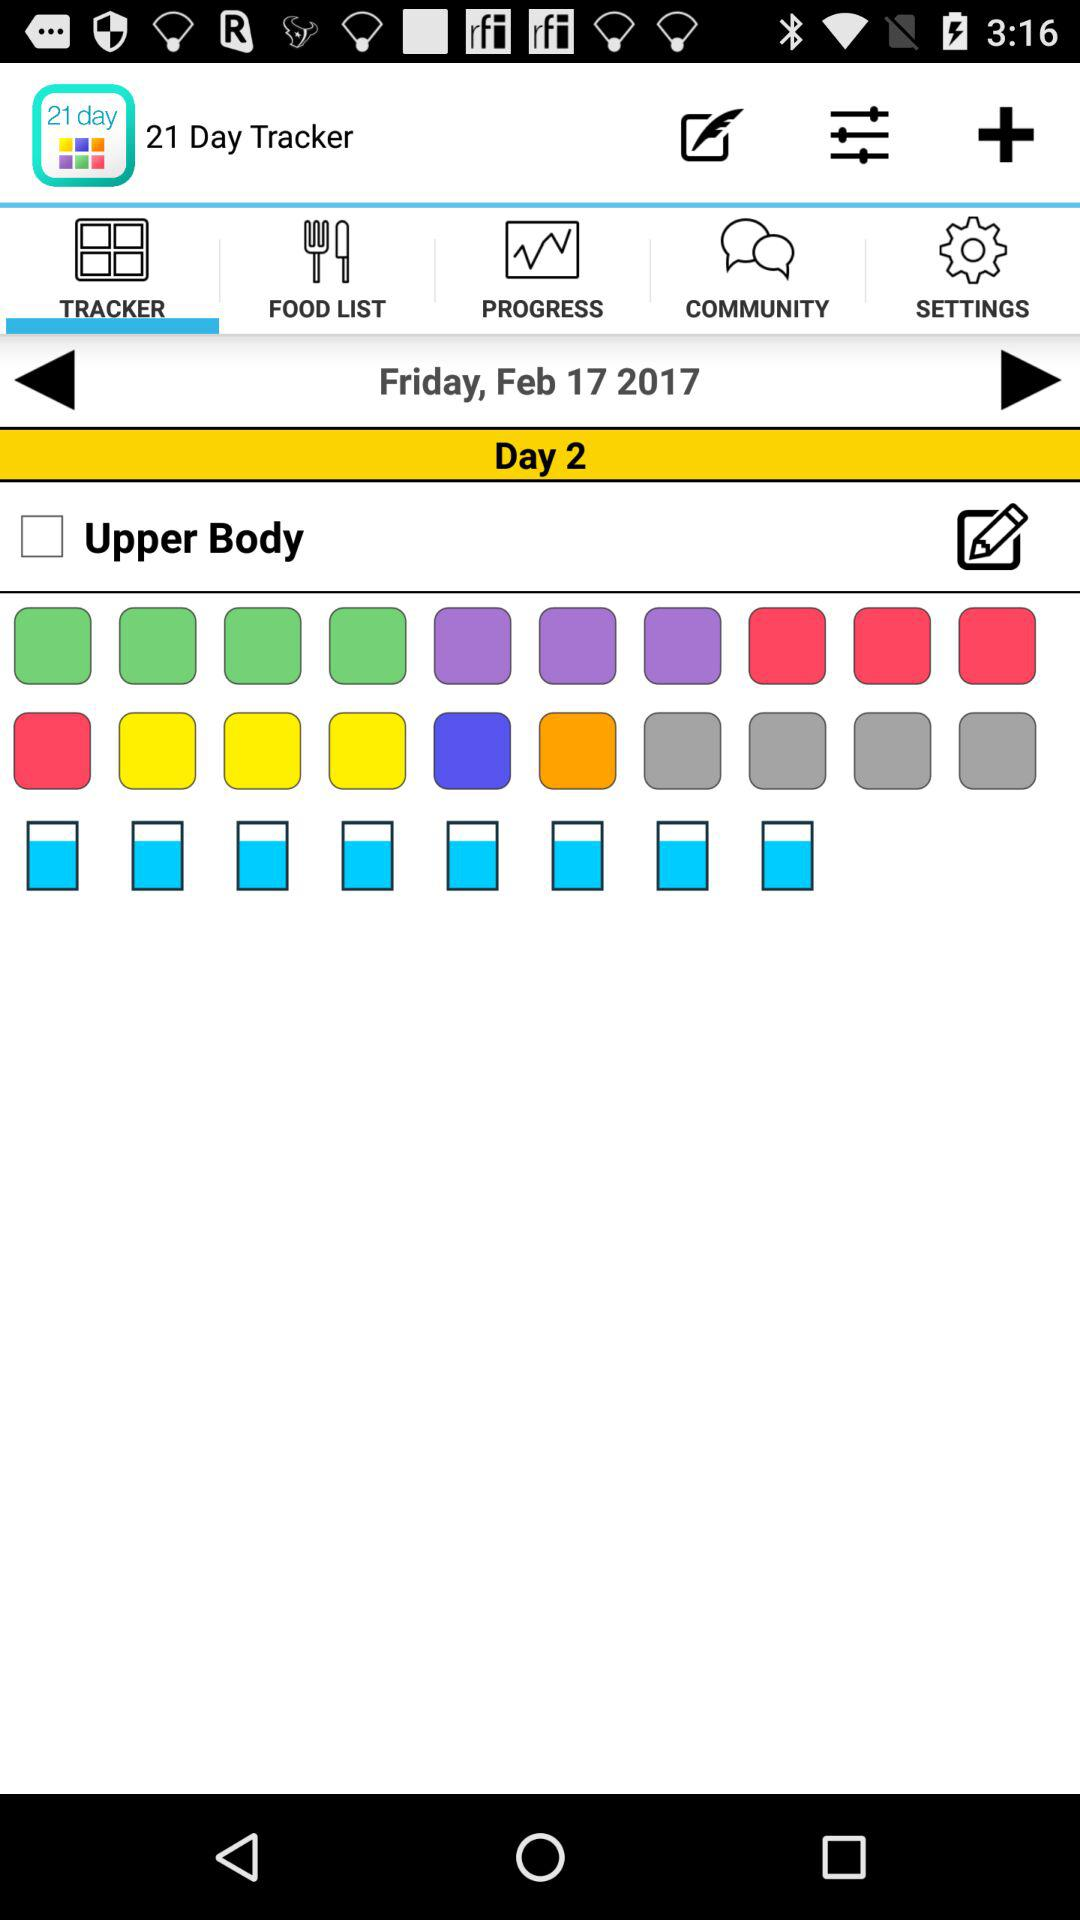Which tab is selected? The selected tab is "TRACKER". 